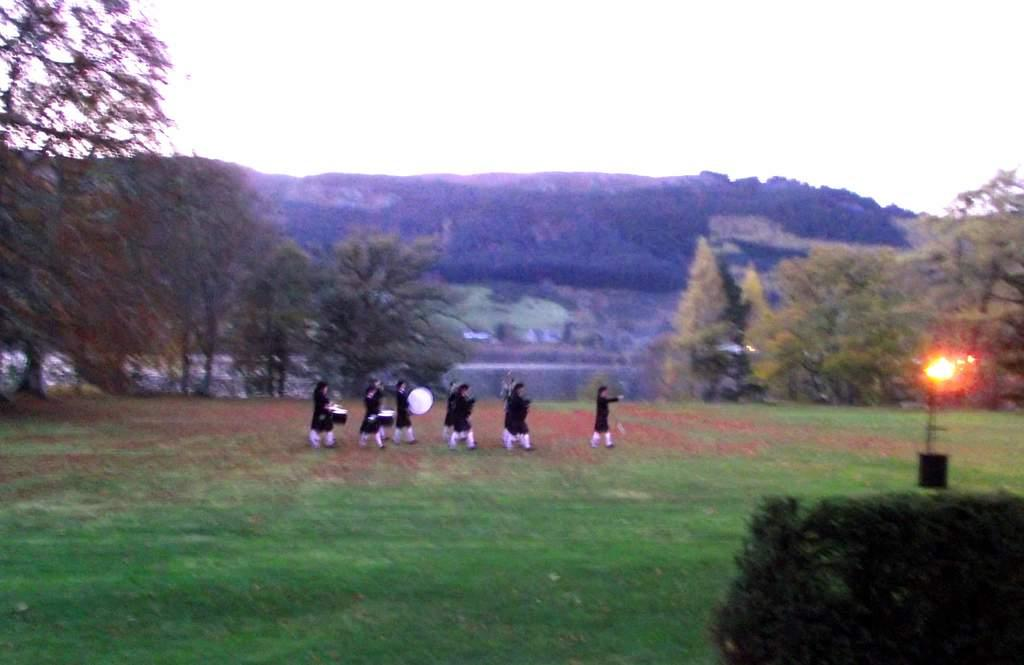What is happening in the image? There is a group of people in the image. What is the setting of the image? The people are walking on land covered with grass. What are some of the people holding? Some of the people are holding drums. What can be seen in the background of the image? There are trees and mountains in the background of the image. Is there a spy observing the group of people from a nearby branch in the image? There is no mention of a spy or a branch in the image; it only shows a group of people walking on grass and holding drums, with trees and mountains in the background. 